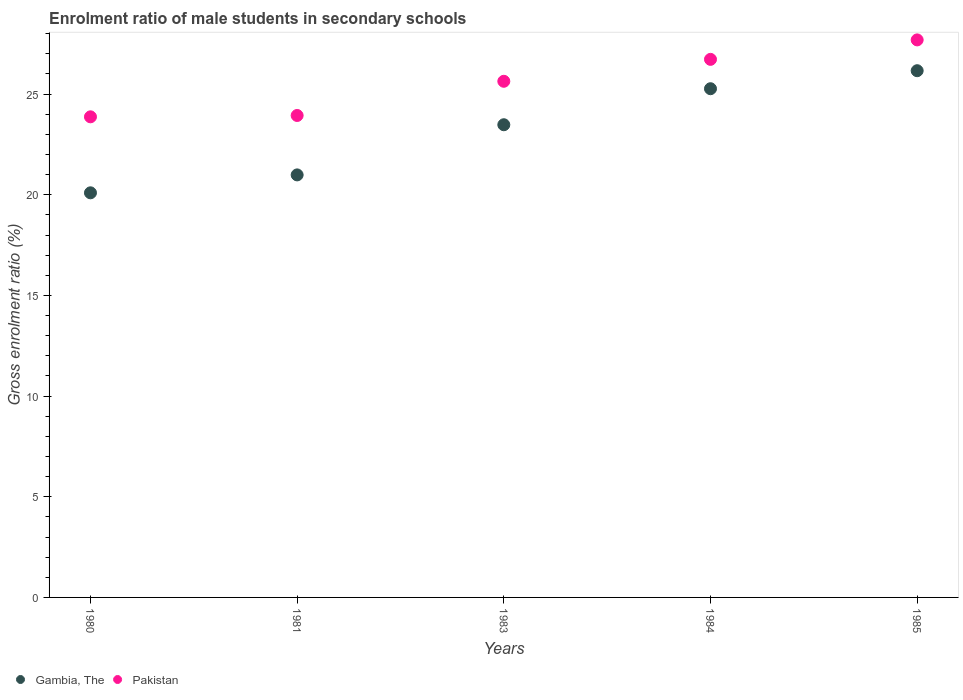Is the number of dotlines equal to the number of legend labels?
Offer a terse response. Yes. What is the enrolment ratio of male students in secondary schools in Gambia, The in 1983?
Your answer should be very brief. 23.48. Across all years, what is the maximum enrolment ratio of male students in secondary schools in Pakistan?
Make the answer very short. 27.69. Across all years, what is the minimum enrolment ratio of male students in secondary schools in Gambia, The?
Provide a succinct answer. 20.1. In which year was the enrolment ratio of male students in secondary schools in Pakistan maximum?
Your answer should be very brief. 1985. What is the total enrolment ratio of male students in secondary schools in Pakistan in the graph?
Make the answer very short. 127.87. What is the difference between the enrolment ratio of male students in secondary schools in Pakistan in 1980 and that in 1985?
Your answer should be very brief. -3.82. What is the difference between the enrolment ratio of male students in secondary schools in Gambia, The in 1983 and the enrolment ratio of male students in secondary schools in Pakistan in 1981?
Your answer should be compact. -0.46. What is the average enrolment ratio of male students in secondary schools in Pakistan per year?
Make the answer very short. 25.57. In the year 1981, what is the difference between the enrolment ratio of male students in secondary schools in Gambia, The and enrolment ratio of male students in secondary schools in Pakistan?
Your answer should be compact. -2.95. What is the ratio of the enrolment ratio of male students in secondary schools in Gambia, The in 1980 to that in 1983?
Give a very brief answer. 0.86. Is the enrolment ratio of male students in secondary schools in Gambia, The in 1980 less than that in 1984?
Make the answer very short. Yes. Is the difference between the enrolment ratio of male students in secondary schools in Gambia, The in 1981 and 1984 greater than the difference between the enrolment ratio of male students in secondary schools in Pakistan in 1981 and 1984?
Give a very brief answer. No. What is the difference between the highest and the second highest enrolment ratio of male students in secondary schools in Pakistan?
Your answer should be very brief. 0.97. What is the difference between the highest and the lowest enrolment ratio of male students in secondary schools in Gambia, The?
Your response must be concise. 6.07. Does the enrolment ratio of male students in secondary schools in Gambia, The monotonically increase over the years?
Ensure brevity in your answer.  Yes. Is the enrolment ratio of male students in secondary schools in Pakistan strictly greater than the enrolment ratio of male students in secondary schools in Gambia, The over the years?
Make the answer very short. Yes. Is the enrolment ratio of male students in secondary schools in Pakistan strictly less than the enrolment ratio of male students in secondary schools in Gambia, The over the years?
Give a very brief answer. No. How many years are there in the graph?
Make the answer very short. 5. Are the values on the major ticks of Y-axis written in scientific E-notation?
Your answer should be compact. No. Does the graph contain any zero values?
Provide a succinct answer. No. How many legend labels are there?
Give a very brief answer. 2. How are the legend labels stacked?
Offer a very short reply. Horizontal. What is the title of the graph?
Give a very brief answer. Enrolment ratio of male students in secondary schools. What is the Gross enrolment ratio (%) in Gambia, The in 1980?
Offer a terse response. 20.1. What is the Gross enrolment ratio (%) of Pakistan in 1980?
Offer a very short reply. 23.87. What is the Gross enrolment ratio (%) of Gambia, The in 1981?
Ensure brevity in your answer.  20.99. What is the Gross enrolment ratio (%) in Pakistan in 1981?
Your answer should be very brief. 23.94. What is the Gross enrolment ratio (%) in Gambia, The in 1983?
Your answer should be compact. 23.48. What is the Gross enrolment ratio (%) of Pakistan in 1983?
Offer a very short reply. 25.64. What is the Gross enrolment ratio (%) in Gambia, The in 1984?
Make the answer very short. 25.27. What is the Gross enrolment ratio (%) in Pakistan in 1984?
Give a very brief answer. 26.73. What is the Gross enrolment ratio (%) in Gambia, The in 1985?
Make the answer very short. 26.16. What is the Gross enrolment ratio (%) in Pakistan in 1985?
Your answer should be compact. 27.69. Across all years, what is the maximum Gross enrolment ratio (%) of Gambia, The?
Give a very brief answer. 26.16. Across all years, what is the maximum Gross enrolment ratio (%) of Pakistan?
Offer a terse response. 27.69. Across all years, what is the minimum Gross enrolment ratio (%) of Gambia, The?
Offer a very short reply. 20.1. Across all years, what is the minimum Gross enrolment ratio (%) of Pakistan?
Your response must be concise. 23.87. What is the total Gross enrolment ratio (%) of Gambia, The in the graph?
Provide a succinct answer. 116. What is the total Gross enrolment ratio (%) of Pakistan in the graph?
Keep it short and to the point. 127.87. What is the difference between the Gross enrolment ratio (%) of Gambia, The in 1980 and that in 1981?
Provide a succinct answer. -0.89. What is the difference between the Gross enrolment ratio (%) of Pakistan in 1980 and that in 1981?
Offer a very short reply. -0.07. What is the difference between the Gross enrolment ratio (%) of Gambia, The in 1980 and that in 1983?
Provide a succinct answer. -3.38. What is the difference between the Gross enrolment ratio (%) in Pakistan in 1980 and that in 1983?
Keep it short and to the point. -1.77. What is the difference between the Gross enrolment ratio (%) in Gambia, The in 1980 and that in 1984?
Give a very brief answer. -5.17. What is the difference between the Gross enrolment ratio (%) in Pakistan in 1980 and that in 1984?
Your answer should be very brief. -2.85. What is the difference between the Gross enrolment ratio (%) in Gambia, The in 1980 and that in 1985?
Your answer should be compact. -6.07. What is the difference between the Gross enrolment ratio (%) in Pakistan in 1980 and that in 1985?
Provide a short and direct response. -3.82. What is the difference between the Gross enrolment ratio (%) in Gambia, The in 1981 and that in 1983?
Provide a short and direct response. -2.49. What is the difference between the Gross enrolment ratio (%) in Pakistan in 1981 and that in 1983?
Your answer should be very brief. -1.7. What is the difference between the Gross enrolment ratio (%) of Gambia, The in 1981 and that in 1984?
Your response must be concise. -4.28. What is the difference between the Gross enrolment ratio (%) of Pakistan in 1981 and that in 1984?
Your answer should be compact. -2.79. What is the difference between the Gross enrolment ratio (%) of Gambia, The in 1981 and that in 1985?
Offer a terse response. -5.18. What is the difference between the Gross enrolment ratio (%) of Pakistan in 1981 and that in 1985?
Your response must be concise. -3.75. What is the difference between the Gross enrolment ratio (%) of Gambia, The in 1983 and that in 1984?
Your answer should be very brief. -1.79. What is the difference between the Gross enrolment ratio (%) in Pakistan in 1983 and that in 1984?
Provide a short and direct response. -1.09. What is the difference between the Gross enrolment ratio (%) in Gambia, The in 1983 and that in 1985?
Offer a terse response. -2.68. What is the difference between the Gross enrolment ratio (%) of Pakistan in 1983 and that in 1985?
Your response must be concise. -2.06. What is the difference between the Gross enrolment ratio (%) in Gambia, The in 1984 and that in 1985?
Ensure brevity in your answer.  -0.89. What is the difference between the Gross enrolment ratio (%) of Pakistan in 1984 and that in 1985?
Make the answer very short. -0.97. What is the difference between the Gross enrolment ratio (%) of Gambia, The in 1980 and the Gross enrolment ratio (%) of Pakistan in 1981?
Your answer should be very brief. -3.84. What is the difference between the Gross enrolment ratio (%) of Gambia, The in 1980 and the Gross enrolment ratio (%) of Pakistan in 1983?
Your answer should be very brief. -5.54. What is the difference between the Gross enrolment ratio (%) of Gambia, The in 1980 and the Gross enrolment ratio (%) of Pakistan in 1984?
Provide a short and direct response. -6.63. What is the difference between the Gross enrolment ratio (%) of Gambia, The in 1980 and the Gross enrolment ratio (%) of Pakistan in 1985?
Ensure brevity in your answer.  -7.6. What is the difference between the Gross enrolment ratio (%) in Gambia, The in 1981 and the Gross enrolment ratio (%) in Pakistan in 1983?
Your answer should be very brief. -4.65. What is the difference between the Gross enrolment ratio (%) of Gambia, The in 1981 and the Gross enrolment ratio (%) of Pakistan in 1984?
Ensure brevity in your answer.  -5.74. What is the difference between the Gross enrolment ratio (%) of Gambia, The in 1981 and the Gross enrolment ratio (%) of Pakistan in 1985?
Your answer should be very brief. -6.71. What is the difference between the Gross enrolment ratio (%) in Gambia, The in 1983 and the Gross enrolment ratio (%) in Pakistan in 1984?
Make the answer very short. -3.25. What is the difference between the Gross enrolment ratio (%) of Gambia, The in 1983 and the Gross enrolment ratio (%) of Pakistan in 1985?
Offer a terse response. -4.21. What is the difference between the Gross enrolment ratio (%) of Gambia, The in 1984 and the Gross enrolment ratio (%) of Pakistan in 1985?
Offer a very short reply. -2.43. What is the average Gross enrolment ratio (%) of Gambia, The per year?
Offer a terse response. 23.2. What is the average Gross enrolment ratio (%) in Pakistan per year?
Give a very brief answer. 25.57. In the year 1980, what is the difference between the Gross enrolment ratio (%) of Gambia, The and Gross enrolment ratio (%) of Pakistan?
Your answer should be compact. -3.77. In the year 1981, what is the difference between the Gross enrolment ratio (%) of Gambia, The and Gross enrolment ratio (%) of Pakistan?
Provide a short and direct response. -2.95. In the year 1983, what is the difference between the Gross enrolment ratio (%) in Gambia, The and Gross enrolment ratio (%) in Pakistan?
Your response must be concise. -2.16. In the year 1984, what is the difference between the Gross enrolment ratio (%) of Gambia, The and Gross enrolment ratio (%) of Pakistan?
Provide a short and direct response. -1.46. In the year 1985, what is the difference between the Gross enrolment ratio (%) of Gambia, The and Gross enrolment ratio (%) of Pakistan?
Provide a short and direct response. -1.53. What is the ratio of the Gross enrolment ratio (%) in Gambia, The in 1980 to that in 1981?
Your answer should be compact. 0.96. What is the ratio of the Gross enrolment ratio (%) of Pakistan in 1980 to that in 1981?
Keep it short and to the point. 1. What is the ratio of the Gross enrolment ratio (%) in Gambia, The in 1980 to that in 1983?
Offer a terse response. 0.86. What is the ratio of the Gross enrolment ratio (%) of Pakistan in 1980 to that in 1983?
Make the answer very short. 0.93. What is the ratio of the Gross enrolment ratio (%) of Gambia, The in 1980 to that in 1984?
Keep it short and to the point. 0.8. What is the ratio of the Gross enrolment ratio (%) in Pakistan in 1980 to that in 1984?
Provide a succinct answer. 0.89. What is the ratio of the Gross enrolment ratio (%) of Gambia, The in 1980 to that in 1985?
Provide a succinct answer. 0.77. What is the ratio of the Gross enrolment ratio (%) of Pakistan in 1980 to that in 1985?
Offer a terse response. 0.86. What is the ratio of the Gross enrolment ratio (%) in Gambia, The in 1981 to that in 1983?
Ensure brevity in your answer.  0.89. What is the ratio of the Gross enrolment ratio (%) in Pakistan in 1981 to that in 1983?
Give a very brief answer. 0.93. What is the ratio of the Gross enrolment ratio (%) in Gambia, The in 1981 to that in 1984?
Make the answer very short. 0.83. What is the ratio of the Gross enrolment ratio (%) in Pakistan in 1981 to that in 1984?
Provide a succinct answer. 0.9. What is the ratio of the Gross enrolment ratio (%) of Gambia, The in 1981 to that in 1985?
Your answer should be very brief. 0.8. What is the ratio of the Gross enrolment ratio (%) of Pakistan in 1981 to that in 1985?
Ensure brevity in your answer.  0.86. What is the ratio of the Gross enrolment ratio (%) in Gambia, The in 1983 to that in 1984?
Offer a very short reply. 0.93. What is the ratio of the Gross enrolment ratio (%) of Pakistan in 1983 to that in 1984?
Provide a short and direct response. 0.96. What is the ratio of the Gross enrolment ratio (%) of Gambia, The in 1983 to that in 1985?
Your response must be concise. 0.9. What is the ratio of the Gross enrolment ratio (%) in Pakistan in 1983 to that in 1985?
Make the answer very short. 0.93. What is the ratio of the Gross enrolment ratio (%) of Gambia, The in 1984 to that in 1985?
Give a very brief answer. 0.97. What is the ratio of the Gross enrolment ratio (%) of Pakistan in 1984 to that in 1985?
Offer a terse response. 0.97. What is the difference between the highest and the second highest Gross enrolment ratio (%) of Gambia, The?
Provide a succinct answer. 0.89. What is the difference between the highest and the second highest Gross enrolment ratio (%) in Pakistan?
Offer a very short reply. 0.97. What is the difference between the highest and the lowest Gross enrolment ratio (%) of Gambia, The?
Make the answer very short. 6.07. What is the difference between the highest and the lowest Gross enrolment ratio (%) in Pakistan?
Offer a terse response. 3.82. 